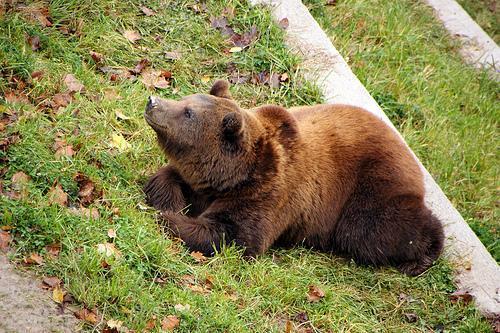How many animals are pictured?
Give a very brief answer. 1. How many brown bears are in the image?
Give a very brief answer. 1. 